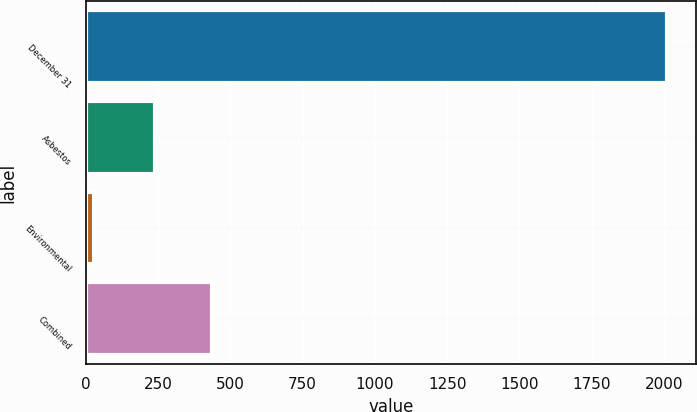<chart> <loc_0><loc_0><loc_500><loc_500><bar_chart><fcel>December 31<fcel>Asbestos<fcel>Environmental<fcel>Combined<nl><fcel>2011<fcel>239<fcel>28<fcel>437.3<nl></chart> 